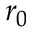<formula> <loc_0><loc_0><loc_500><loc_500>r _ { 0 }</formula> 